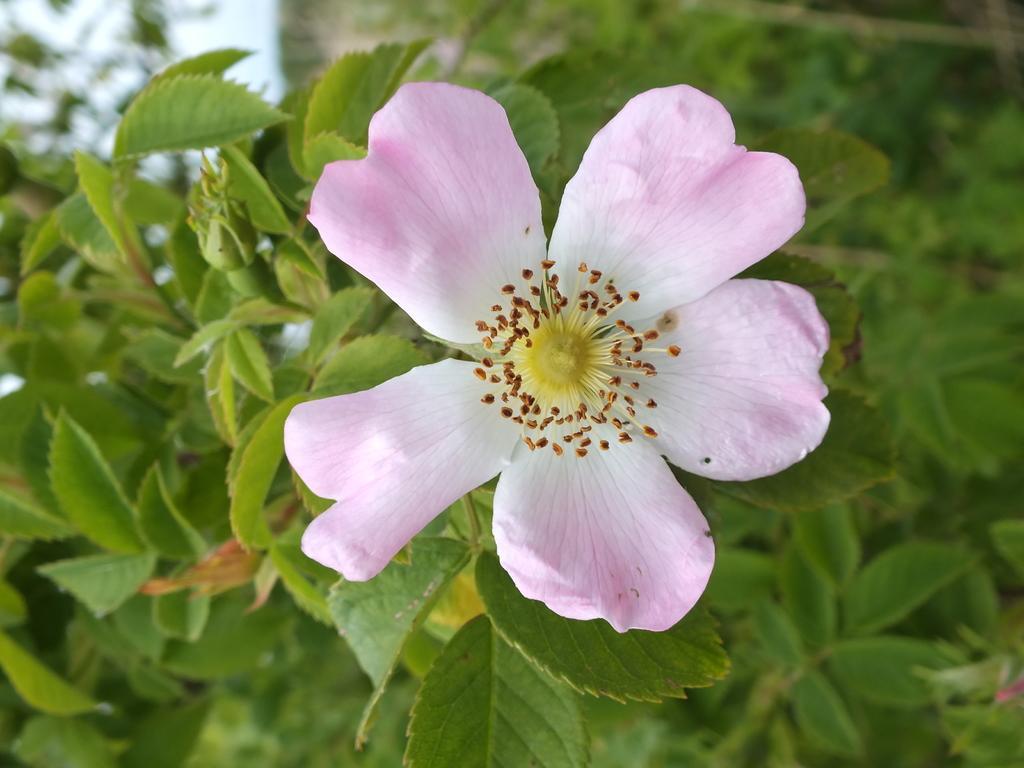Can you describe this image briefly? In this image we can see a flower, and plants, also the background is blurred. 